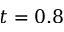Convert formula to latex. <formula><loc_0><loc_0><loc_500><loc_500>t = 0 . 8</formula> 